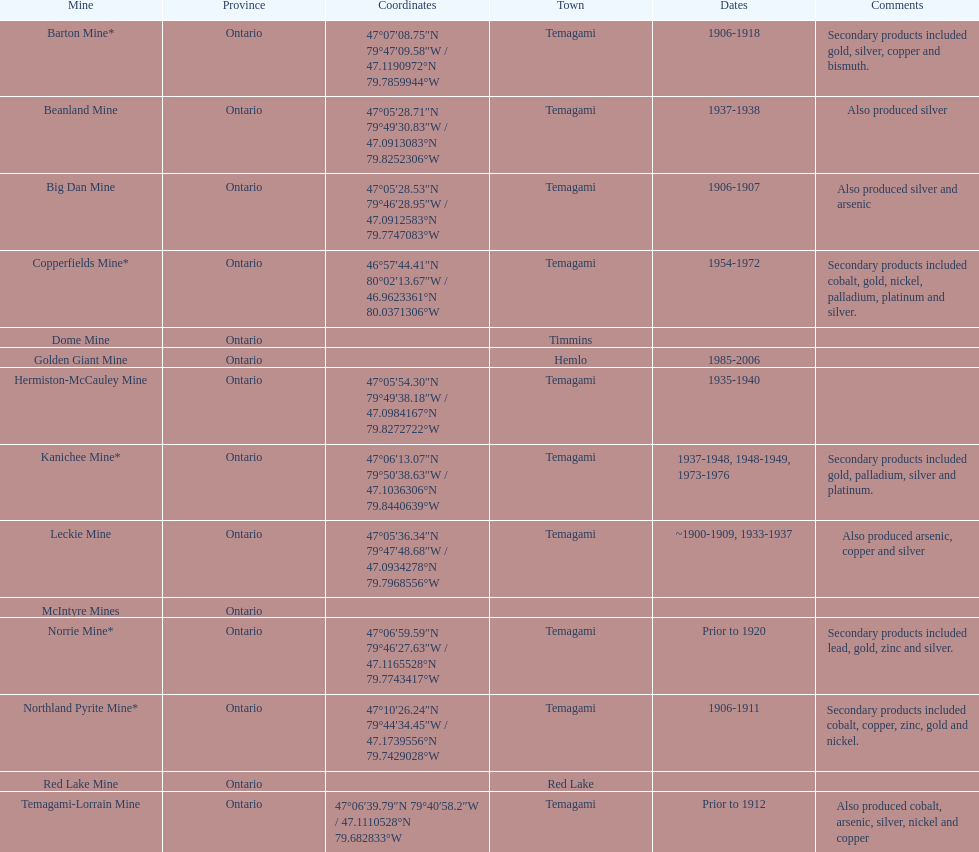Give me the full table as a dictionary. {'header': ['Mine', 'Province', 'Coordinates', 'Town', 'Dates', 'Comments'], 'rows': [['Barton Mine*', 'Ontario', '47°07′08.75″N 79°47′09.58″W\ufeff / \ufeff47.1190972°N 79.7859944°W', 'Temagami', '1906-1918', 'Secondary products included gold, silver, copper and bismuth.'], ['Beanland Mine', 'Ontario', '47°05′28.71″N 79°49′30.83″W\ufeff / \ufeff47.0913083°N 79.8252306°W', 'Temagami', '1937-1938', 'Also produced silver'], ['Big Dan Mine', 'Ontario', '47°05′28.53″N 79°46′28.95″W\ufeff / \ufeff47.0912583°N 79.7747083°W', 'Temagami', '1906-1907', 'Also produced silver and arsenic'], ['Copperfields Mine*', 'Ontario', '46°57′44.41″N 80°02′13.67″W\ufeff / \ufeff46.9623361°N 80.0371306°W', 'Temagami', '1954-1972', 'Secondary products included cobalt, gold, nickel, palladium, platinum and silver.'], ['Dome Mine', 'Ontario', '', 'Timmins', '', ''], ['Golden Giant Mine', 'Ontario', '', 'Hemlo', '1985-2006', ''], ['Hermiston-McCauley Mine', 'Ontario', '47°05′54.30″N 79°49′38.18″W\ufeff / \ufeff47.0984167°N 79.8272722°W', 'Temagami', '1935-1940', ''], ['Kanichee Mine*', 'Ontario', '47°06′13.07″N 79°50′38.63″W\ufeff / \ufeff47.1036306°N 79.8440639°W', 'Temagami', '1937-1948, 1948-1949, 1973-1976', 'Secondary products included gold, palladium, silver and platinum.'], ['Leckie Mine', 'Ontario', '47°05′36.34″N 79°47′48.68″W\ufeff / \ufeff47.0934278°N 79.7968556°W', 'Temagami', '~1900-1909, 1933-1937', 'Also produced arsenic, copper and silver'], ['McIntyre Mines', 'Ontario', '', '', '', ''], ['Norrie Mine*', 'Ontario', '47°06′59.59″N 79°46′27.63″W\ufeff / \ufeff47.1165528°N 79.7743417°W', 'Temagami', 'Prior to 1920', 'Secondary products included lead, gold, zinc and silver.'], ['Northland Pyrite Mine*', 'Ontario', '47°10′26.24″N 79°44′34.45″W\ufeff / \ufeff47.1739556°N 79.7429028°W', 'Temagami', '1906-1911', 'Secondary products included cobalt, copper, zinc, gold and nickel.'], ['Red Lake Mine', 'Ontario', '', 'Red Lake', '', ''], ['Temagami-Lorrain Mine', 'Ontario', '47°06′39.79″N 79°40′58.2″W\ufeff / \ufeff47.1110528°N 79.682833°W', 'Temagami', 'Prior to 1912', 'Also produced cobalt, arsenic, silver, nickel and copper']]} What town is listed the most? Temagami. 